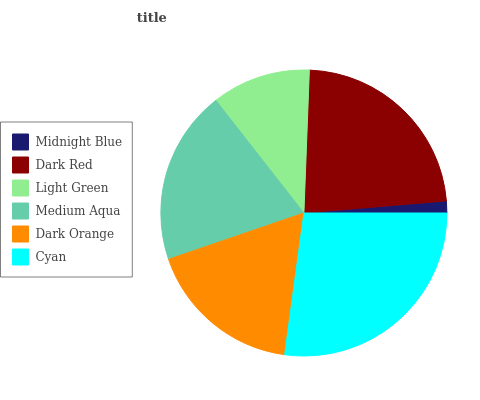Is Midnight Blue the minimum?
Answer yes or no. Yes. Is Cyan the maximum?
Answer yes or no. Yes. Is Dark Red the minimum?
Answer yes or no. No. Is Dark Red the maximum?
Answer yes or no. No. Is Dark Red greater than Midnight Blue?
Answer yes or no. Yes. Is Midnight Blue less than Dark Red?
Answer yes or no. Yes. Is Midnight Blue greater than Dark Red?
Answer yes or no. No. Is Dark Red less than Midnight Blue?
Answer yes or no. No. Is Medium Aqua the high median?
Answer yes or no. Yes. Is Dark Orange the low median?
Answer yes or no. Yes. Is Cyan the high median?
Answer yes or no. No. Is Light Green the low median?
Answer yes or no. No. 